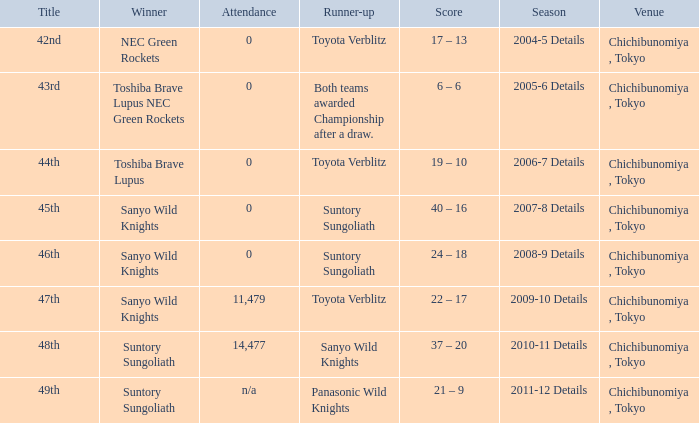What is the Score when the winner was sanyo wild knights, and a Runner-up of suntory sungoliath? 40 – 16, 24 – 18. 